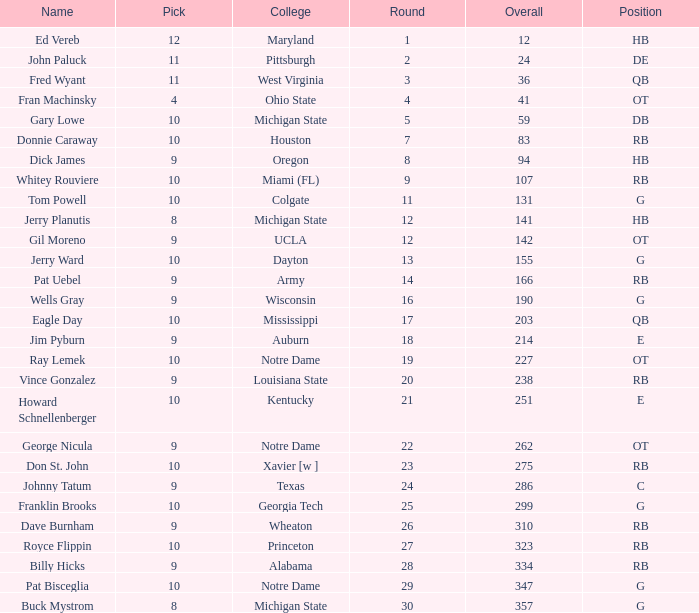What is the total number of overall picks that were after pick 9 and went to Auburn College? 0.0. 